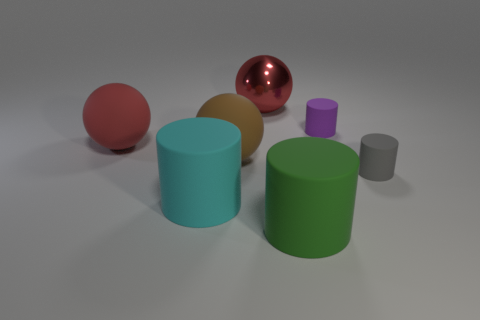Add 1 large green matte cylinders. How many objects exist? 8 Subtract all cylinders. How many objects are left? 3 Add 2 green things. How many green things are left? 3 Add 1 big gray metallic cubes. How many big gray metallic cubes exist? 1 Subtract 1 cyan cylinders. How many objects are left? 6 Subtract all small green metal blocks. Subtract all red matte balls. How many objects are left? 6 